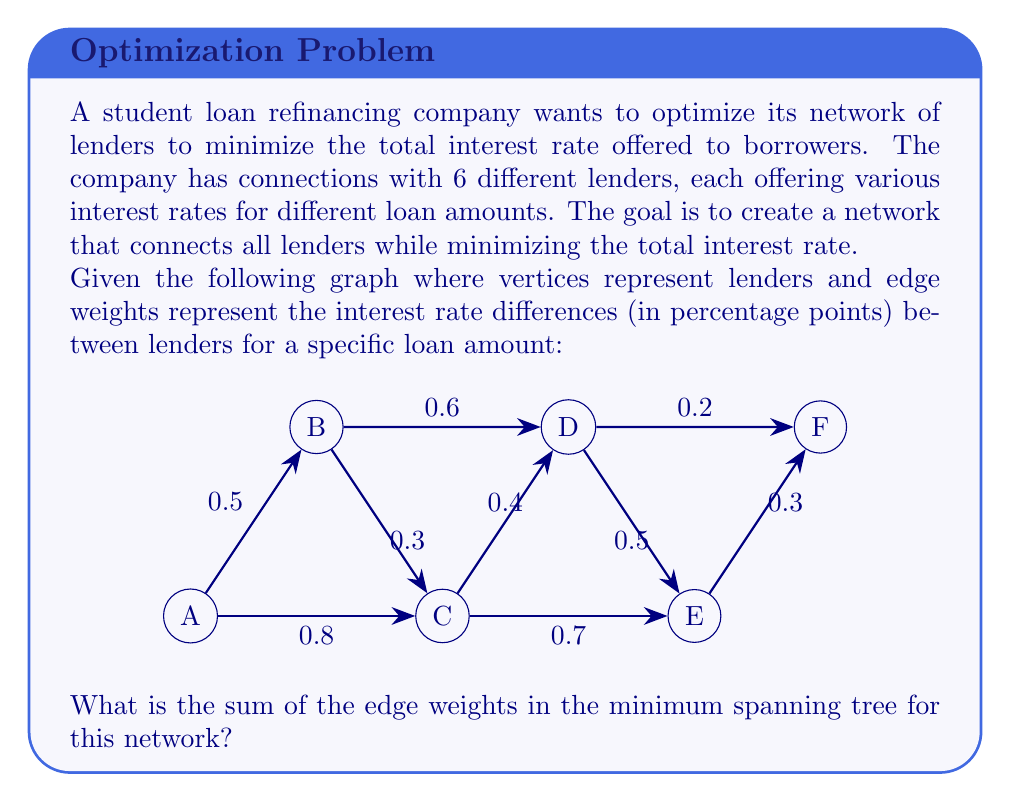Solve this math problem. To solve this problem, we need to find the minimum spanning tree (MST) of the given graph. The MST will represent the optimal network of lenders that minimizes the total interest rate difference. We can use Kruskal's algorithm to find the MST:

1. Sort all edges by weight in ascending order:
   (D, F): 0.2
   (B, C): 0.3
   (E, F): 0.3
   (C, D): 0.4
   (A, B): 0.5
   (D, E): 0.5
   (B, D): 0.6
   (C, E): 0.7
   (A, C): 0.8

2. Start with an empty set of edges and add edges in order, skipping those that would create a cycle:

   - Add (D, F): 0.2
   - Add (B, C): 0.3
   - Add (E, F): 0.3
   - Add (C, D): 0.4
   - Add (A, B): 0.5

3. We now have 5 edges connecting all 6 vertices, forming the MST.

4. Calculate the sum of the edge weights in the MST:

   $$0.2 + 0.3 + 0.3 + 0.4 + 0.5 = 1.7$$

Therefore, the sum of the edge weights in the minimum spanning tree is 1.7 percentage points.
Answer: 1.7 percentage points 